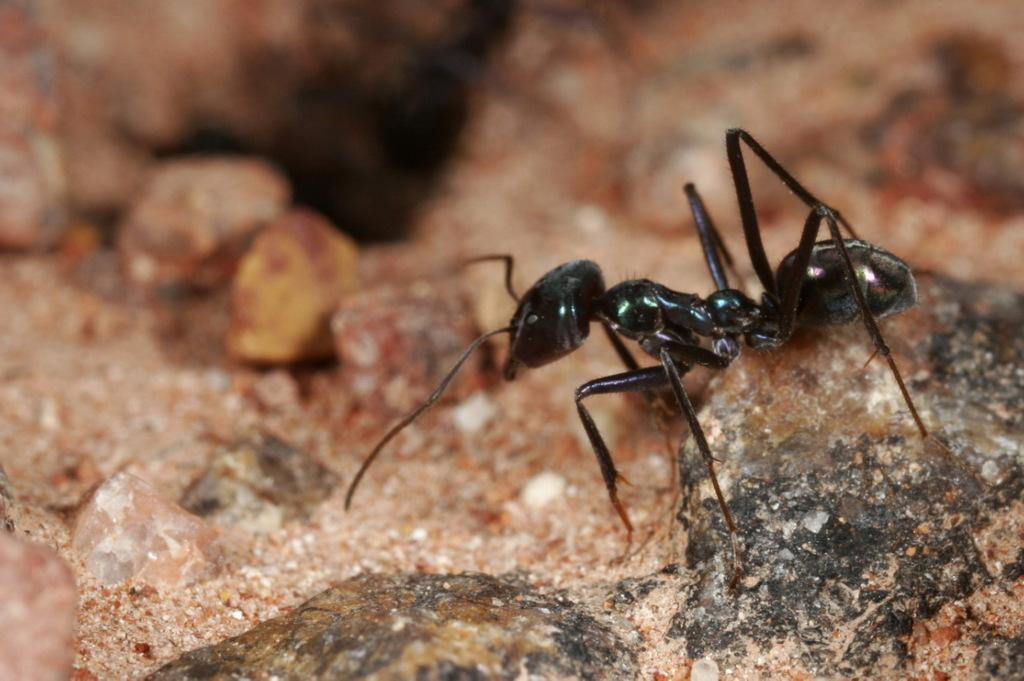What color is the pant that is visible in the image? The pant is black in color. Can you describe the location of the black pant in the image? The black pant might be on a rock. What type of cave can be seen in the image? There is no cave present in the image; it only features a black pant that might be on a rock. What causes the shade in the image? There is no shade mentioned or visible in the image, as it only features a black pant that might be on a rock. 